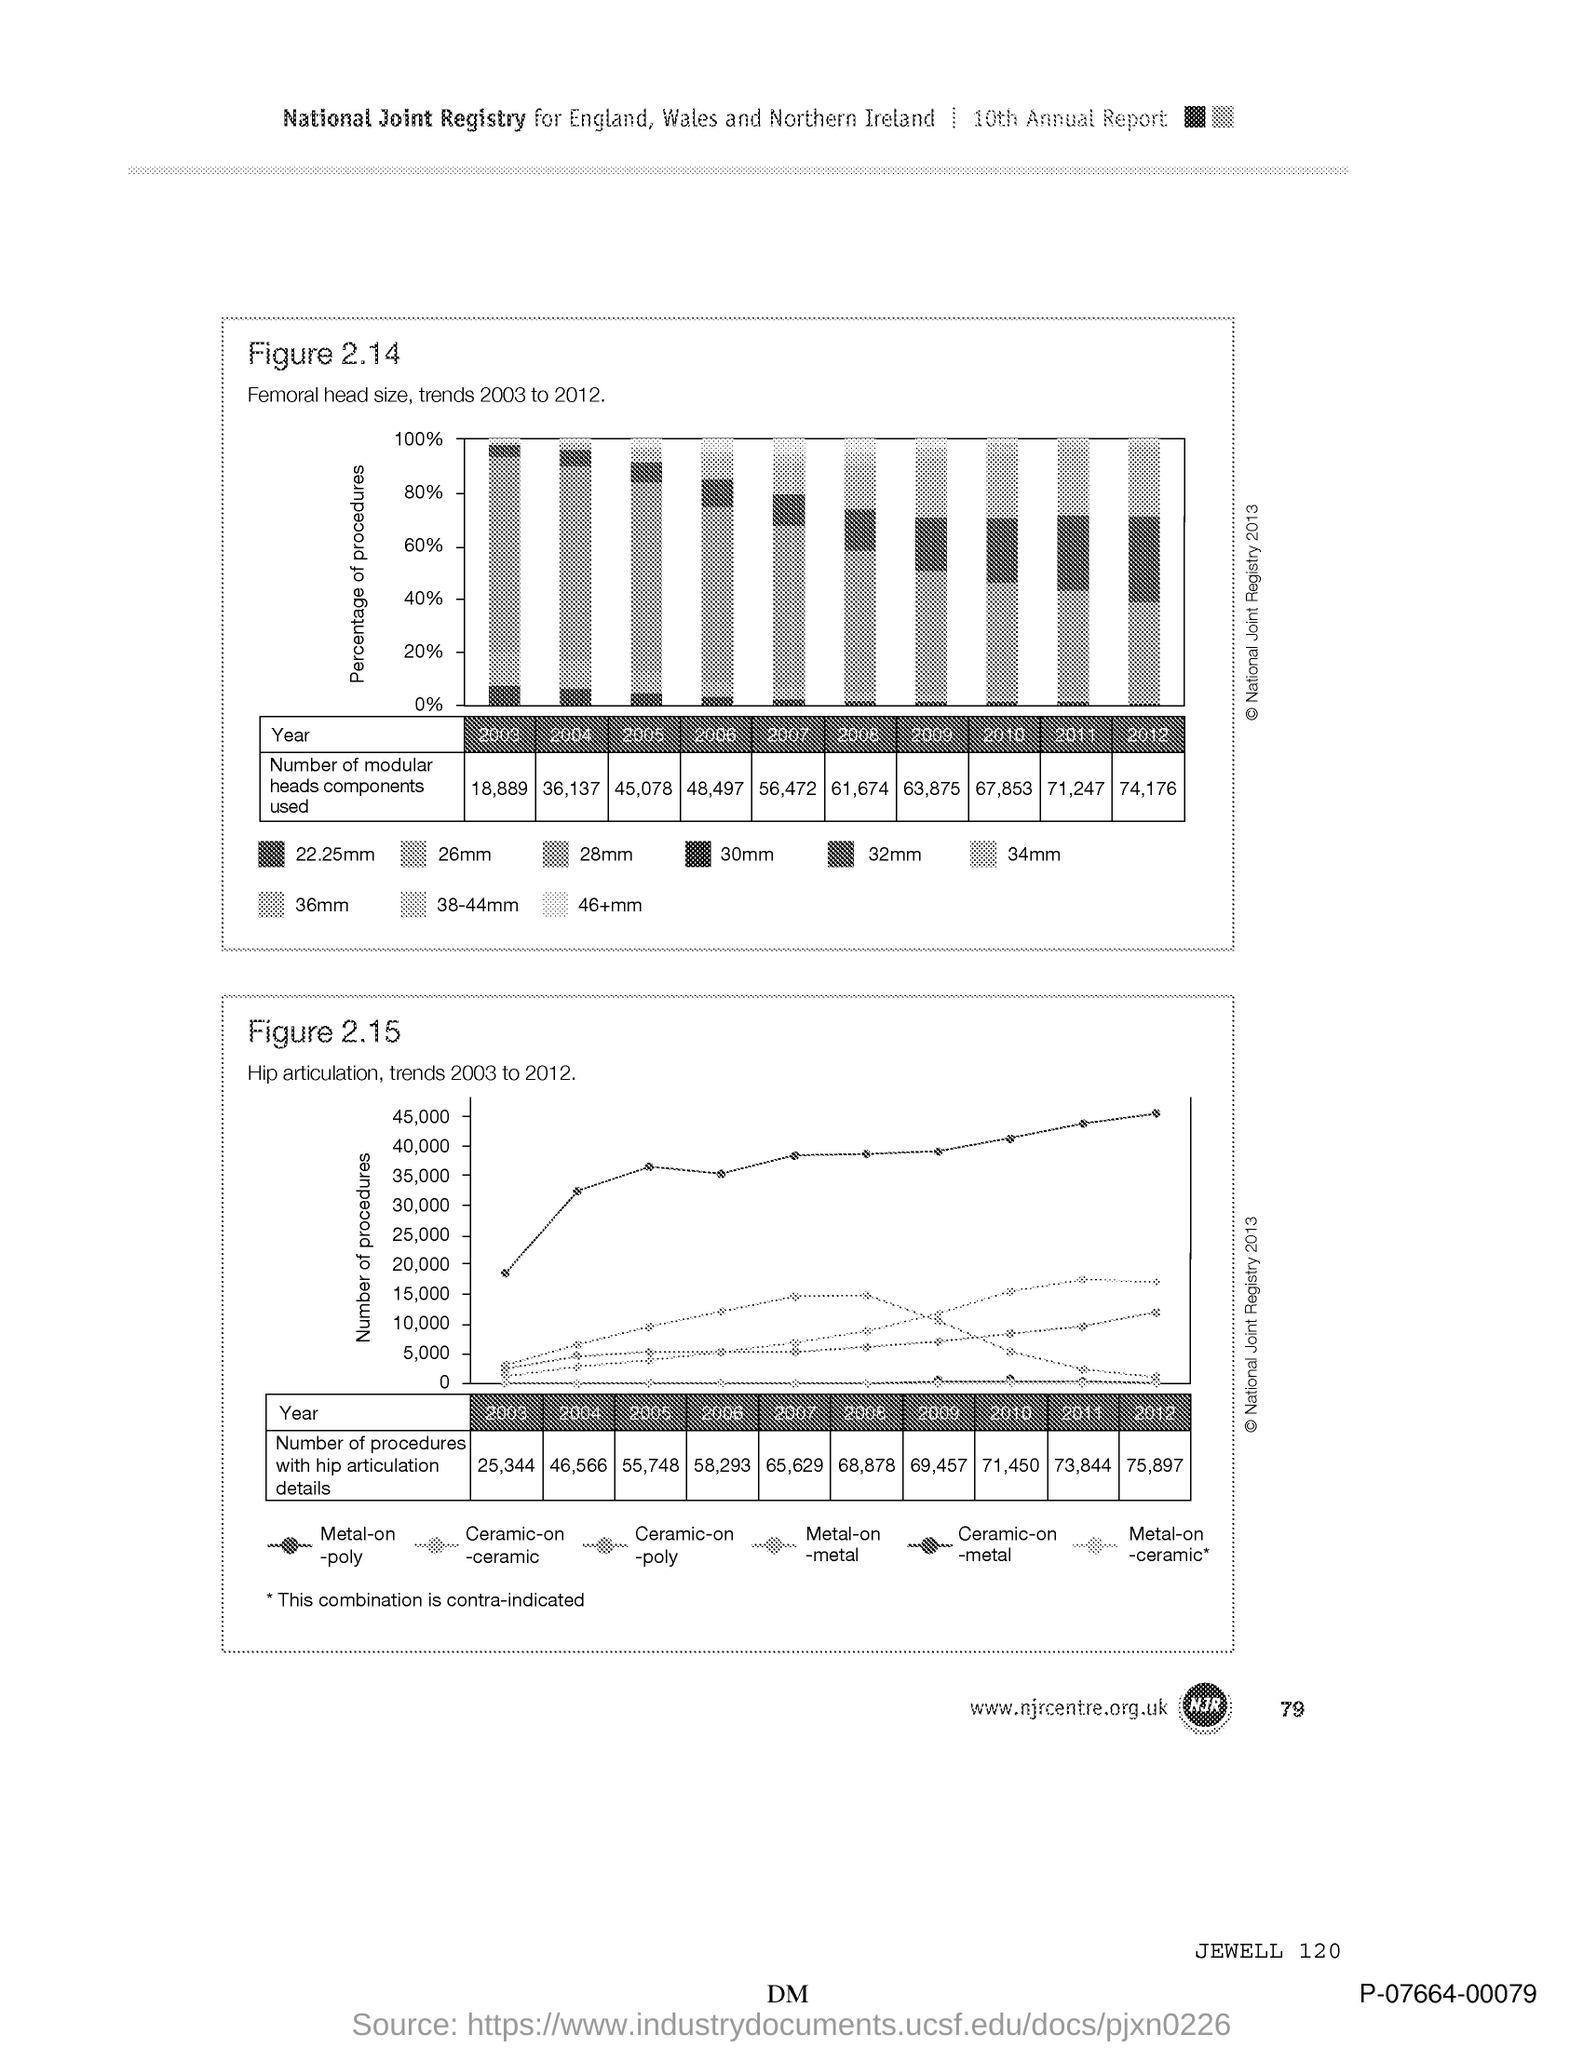What is the number at bottom right of the page?
Provide a short and direct response. 79. 